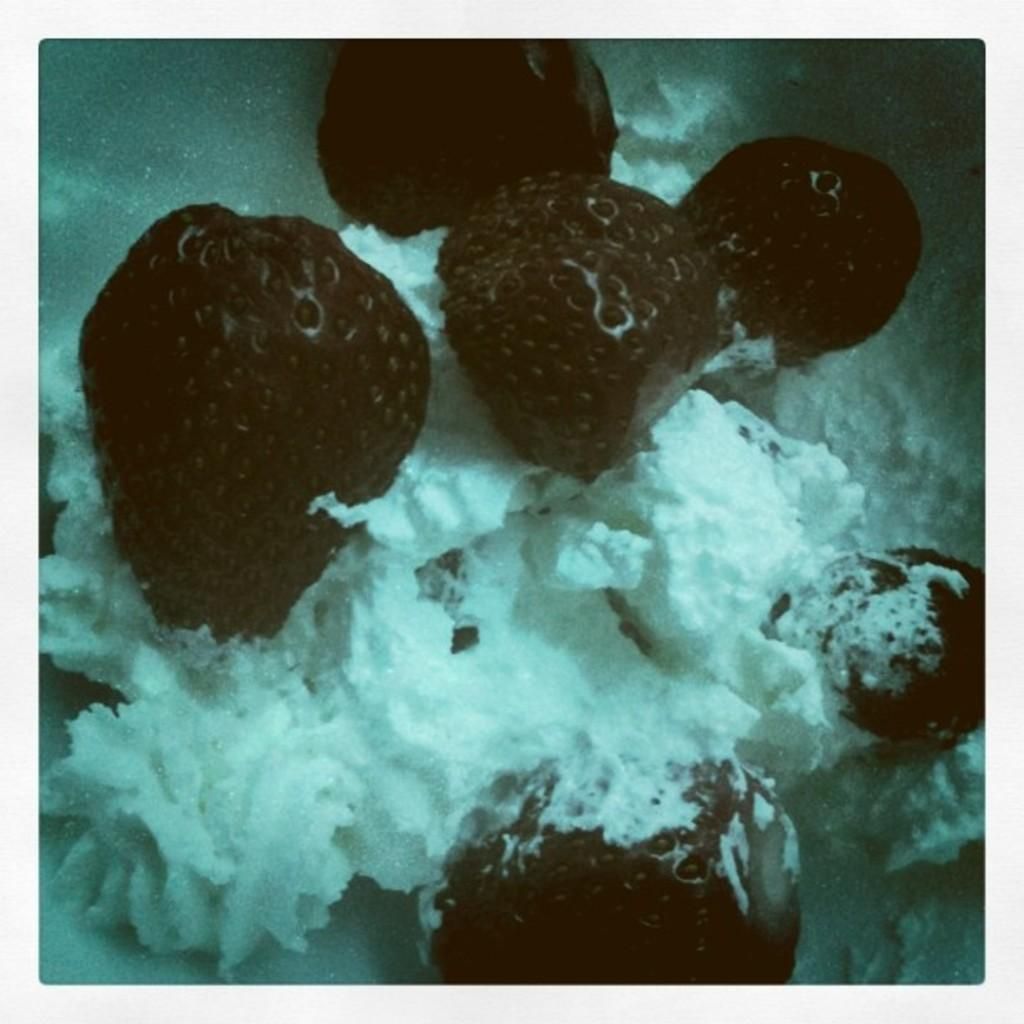What is the main subject of the image? The main subject of the image is an ice cream. What toppings are on the ice cream? The ice cream has strawberries on it. What type of volleyball is being served in the soup by the secretary in the image? There is no volleyball, soup, or secretary present in the image; it only features an ice cream with strawberries on it. 